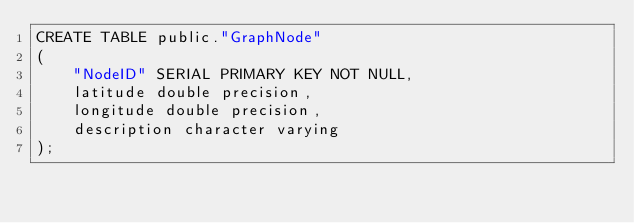Convert code to text. <code><loc_0><loc_0><loc_500><loc_500><_SQL_>CREATE TABLE public."GraphNode"
(
    "NodeID" SERIAL PRIMARY KEY NOT NULL,
    latitude double precision,
    longitude double precision,
    description character varying
);
</code> 